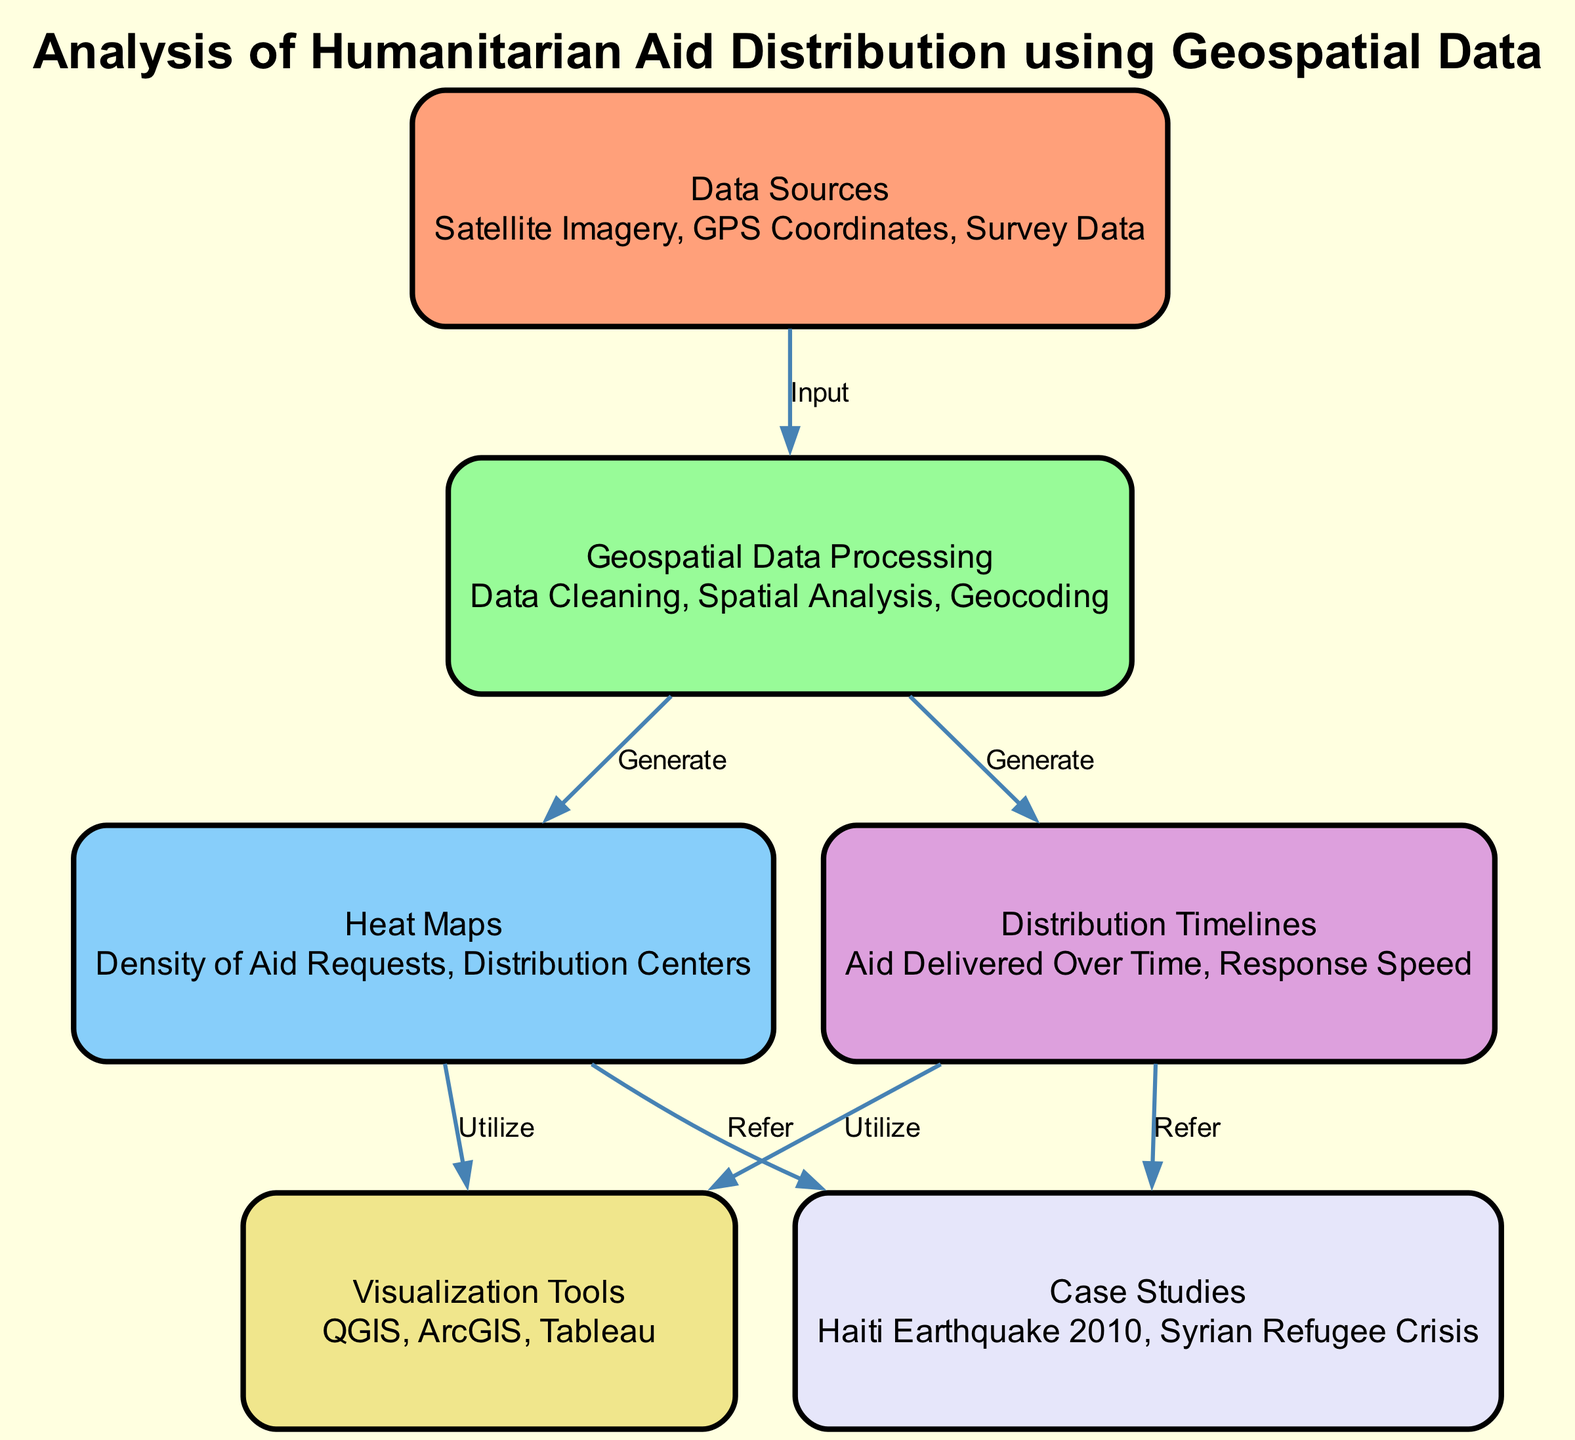What are the data sources listed in the diagram? The diagram mentions three data sources: Satellite Imagery, GPS Coordinates, and Survey Data, which are highlighted under the 'Data Sources' node.
Answer: Satellite Imagery, GPS Coordinates, Survey Data How many nodes are present in the diagram? There are six nodes in total, which are Data Sources, Geospatial Data Processing, Heat Maps, Distribution Timelines, Visualization Tools, and Case Studies, as shown in the diagram.
Answer: 6 What is the output of the 'Geospatial Data Processing' node? The 'Geospatial Data Processing' node generates two outputs, which are Heat Maps and Distribution Timelines, representing the processes resulting from data cleaning and spatial analysis.
Answer: Heat Maps, Distribution Timelines Which visualization tools are associated with heat maps? The 'Visualization Tools' node connects with 'Heat Maps' through a utilization edge, indicating that QGIS, ArcGIS, and Tableau are used to visualize heat maps derived from geospatial data.
Answer: QGIS, ArcGIS, Tableau What relationship exists between the 'Heat Maps' and 'Case Studies'? The diagram captures a referential edge from 'Heat Maps' to 'Case Studies', indicating that heat maps are referenced in case studies like Haiti Earthquake 2010 and Syrian Refugee Crisis for analysis of aid distribution.
Answer: Refer What type of analysis is performed on the 'Geospatial Data Processing'? The diagram specifies that 'Geospatial Data Processing' involves Data Cleaning, Spatial Analysis, and Geocoding, which encompass the techniques employed to process geospatial data effectively.
Answer: Data Cleaning, Spatial Analysis, Geocoding Which two major humanitarian crises are cited as case studies? The diagram lists Haiti Earthquake 2010 and Syrian Refugee Crisis within the 'Case Studies' node, highlighting these events as important references for analyzing aid distribution.
Answer: Haiti Earthquake 2010, Syrian Refugee Crisis What is highlighted as an important metric in 'Distribution Timelines'? The 'Distribution Timelines' node emphasizes two critical metrics: Aid Delivered Over Time and Response Speed, which are integral for assessing the efficiency of aid distribution.
Answer: Aid Delivered Over Time, Response Speed What does the label on the edge from 'Data Sources' to 'Geospatial Data Processing' signify? The label on the edge indicates 'Input', showing the flow of information from 'Data Sources' to 'Geospatial Data Processing', confirming that the latter processes the input data collected.
Answer: Input 